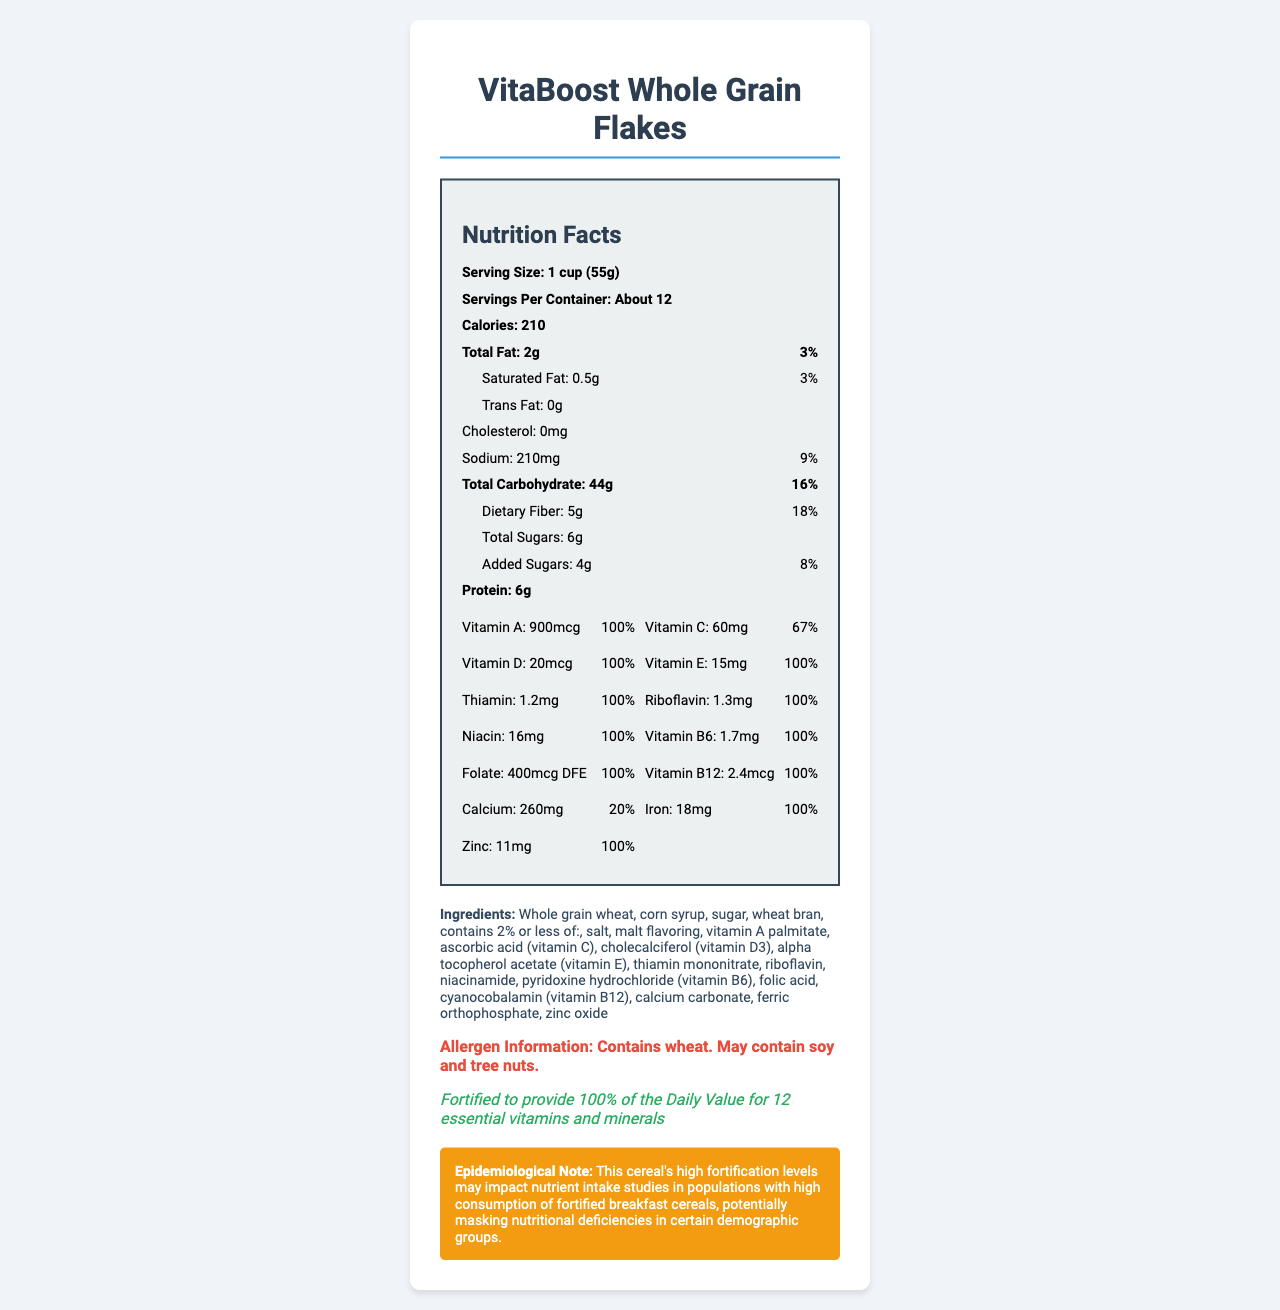what is the serving size of VitaBoost Whole Grain Flakes? The serving size is clearly mentioned at the top of the nutrition facts section.
Answer: 1 cup (55g) how many calories does one serving of this cereal provide? The number of calories per serving is listed prominently in the nutrition facts section under the serving size.
Answer: 210 calories what percentage of the daily value of dietary fiber does one serving provide? The daily value percentage for dietary fiber is given next to the amount (5g) in the nutrition facts section.
Answer: 18% how many grams of sugar are in one serving of this cereal? The total sugars are listed as 6g in the nutrition facts section.
Answer: 6g how much sodium is in one serving, and what percentage of the daily value does it represent? Both the amount of sodium (210mg) and its daily value percentage (9%) are listed in the nutrition facts section.
Answer: 210mg, 9% which vitamins and minerals are present at 100% of their daily value? A. Vitamin C, Vitamin D, Calcium B. Vitamin A, Vitamin E, Vitamin B6 C. Vitamin B12, Iron, Zinc D. All of the above Vitamins and minerals like Vitamin A, Vitamin E, and Vitamin B6 are at 100% daily value.
Answer: B how many servings are there per container? A. 10 B. 12 C. About 12 "About 12" servings per container is mentioned at the top of the nutrition facts section.
Answer: C is there any cholesterol in this cereal? The document specifies that there is 0mg of cholesterol.
Answer: No is this product fortified with essential nutrients? The fortification statement clearly mentions that the cereal is fortified to provide 100% of the daily value for 12 essential vitamins and minerals.
Answer: Yes summarize the main idea of this document. The document includes an overview of serving size, nutrient content, added vitamins and minerals, and a note on the potential epidemiological implications of high fortification levels.
Answer: This document provides the Nutrition Facts Label for VitaBoost Whole Grain Flakes, a fortified breakfast cereal. It highlights various nutrients such as vitamins and minerals, detailed serving information, ingredients, allergen information, and the fortification statement outlining the product's contribution to daily nutritional intake. what is the geographic distribution of this product's consumption? The document does not provide information on the geographic distribution of the product's consumption.
Answer: Cannot be determined 